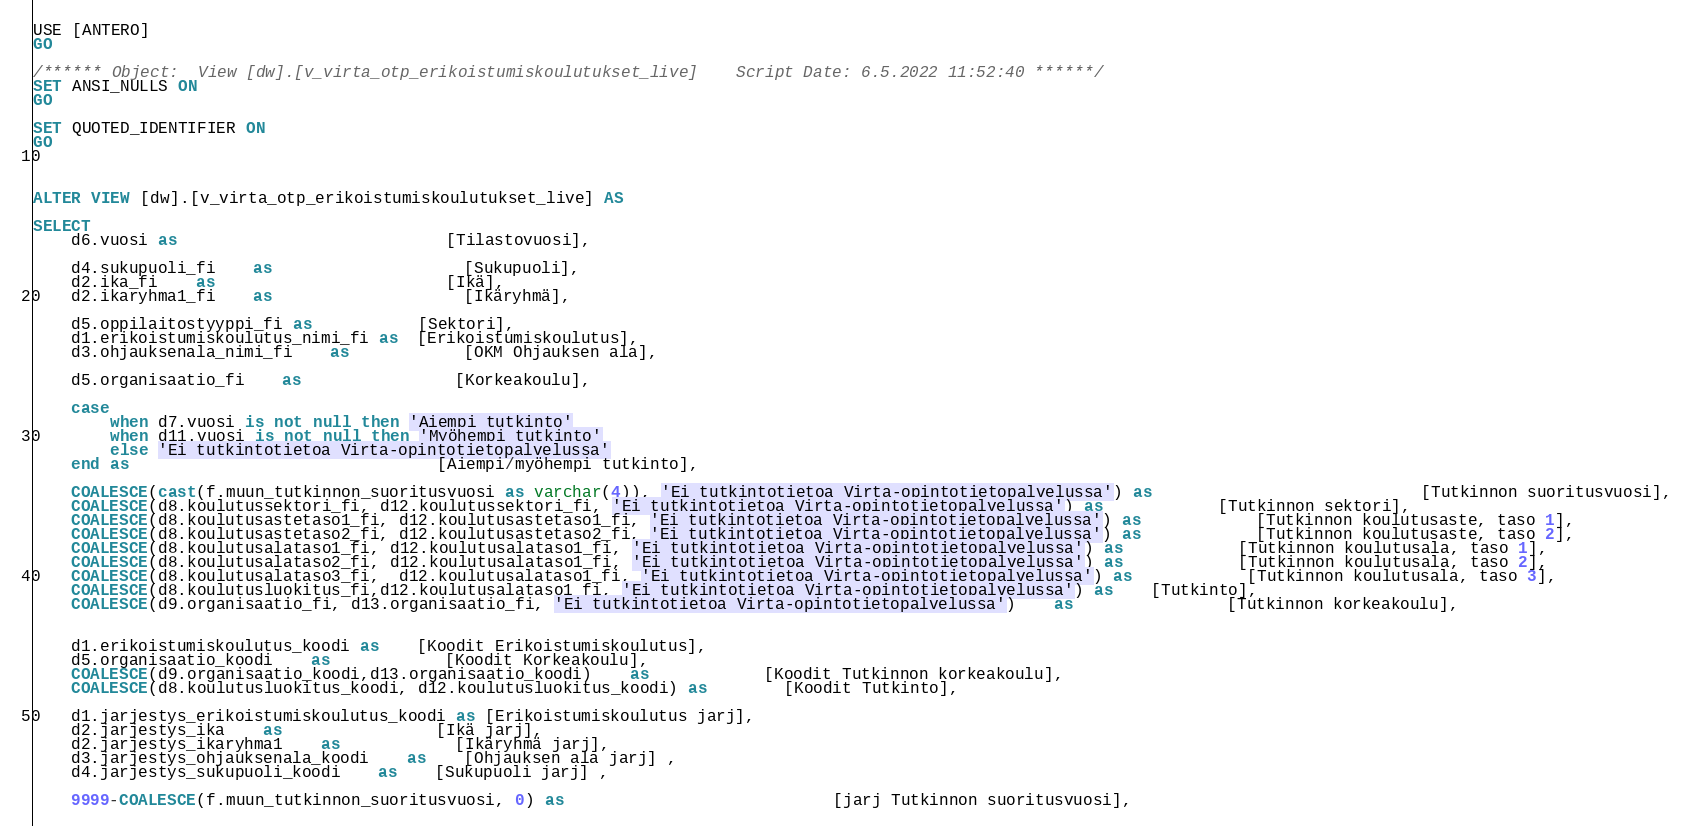Convert code to text. <code><loc_0><loc_0><loc_500><loc_500><_SQL_>USE [ANTERO]
GO

/****** Object:  View [dw].[v_virta_otp_erikoistumiskoulutukset_live]    Script Date: 6.5.2022 11:52:40 ******/
SET ANSI_NULLS ON
GO

SET QUOTED_IDENTIFIER ON
GO



ALTER VIEW [dw].[v_virta_otp_erikoistumiskoulutukset_live] AS

SELECT   	
    d6.vuosi as							[Tilastovuosi],

	d4.sukupuoli_fi	as					[Sukupuoli],
	d2.ika_fi	as						[Ikä],
	d2.ikaryhma1_fi	as					[Ikäryhmä],
	
	d5.oppilaitostyyppi_fi as           [Sektori],
	d1.erikoistumiskoulutus_nimi_fi as  [Erikoistumiskoulutus],
	d3.ohjauksenala_nimi_fi	as			[OKM Ohjauksen ala],

	d5.organisaatio_fi	as				[Korkeakoulu],

	case 
		when d7.vuosi is not null then 'Aiempi tutkinto'
		when d11.vuosi is not null then 'Myöhempi tutkinto'
		else 'Ei tutkintotietoa Virta-opintotietopalvelussa'
	end as								[Aiempi/myöhempi tutkinto],

	COALESCE(cast(f.muun_tutkinnon_suoritusvuosi as varchar(4)), 'Ei tutkintotietoa Virta-opintotietopalvelussa') as							[Tutkinnon suoritusvuosi],
	COALESCE(d8.koulutussektori_fi, d12.koulutussektori_fi, 'Ei tutkintotietoa Virta-opintotietopalvelussa') as			[Tutkinnon sektori],
	COALESCE(d8.koulutusastetaso1_fi, d12.koulutusastetaso1_fi, 'Ei tutkintotietoa Virta-opintotietopalvelussa') as			[Tutkinnon koulutusaste, taso 1],
	COALESCE(d8.koulutusastetaso2_fi, d12.koulutusastetaso2_fi, 'Ei tutkintotietoa Virta-opintotietopalvelussa') as			[Tutkinnon koulutusaste, taso 2],
	COALESCE(d8.koulutusalataso1_fi, d12.koulutusalataso1_fi, 'Ei tutkintotietoa Virta-opintotietopalvelussa') as			[Tutkinnon koulutusala, taso 1],
	COALESCE(d8.koulutusalataso2_fi, d12.koulutusalataso1_fi, 'Ei tutkintotietoa Virta-opintotietopalvelussa') as			[Tutkinnon koulutusala, taso 2],
	COALESCE(d8.koulutusalataso3_fi,  d12.koulutusalataso1_fi, 'Ei tutkintotietoa Virta-opintotietopalvelussa') as			[Tutkinnon koulutusala, taso 3],
	COALESCE(d8.koulutusluokitus_fi,d12.koulutusalataso1_fi, 'Ei tutkintotietoa Virta-opintotietopalvelussa') as	[Tutkinto],
	COALESCE(d9.organisaatio_fi, d13.organisaatio_fi, 'Ei tutkintotietoa Virta-opintotietopalvelussa')	as				[Tutkinnon korkeakoulu],

	
	d1.erikoistumiskoulutus_koodi as    [Koodit Erikoistumiskoulutus],
	d5.organisaatio_koodi	as			[Koodit Korkeakoulu],
	COALESCE(d9.organisaatio_koodi,d13.organisaatio_koodi)	as			[Koodit Tutkinnon korkeakoulu],
	COALESCE(d8.koulutusluokitus_koodi, d12.koulutusluokitus_koodi) as		[Koodit Tutkinto],

	d1.jarjestys_erikoistumiskoulutus_koodi as [Erikoistumiskoulutus jarj],
	d2.jarjestys_ika	as				[Ikä jarj],
	d2.jarjestys_ikaryhma1	as			[Ikäryhmä jarj],
	d3.jarjestys_ohjauksenala_koodi	as	[Ohjauksen ala jarj] ,  
	d4.jarjestys_sukupuoli_koodi	as	[Sukupuoli jarj] ,

	9999-COALESCE(f.muun_tutkinnon_suoritusvuosi, 0) as							[jarj Tutkinnon suoritusvuosi],</code> 